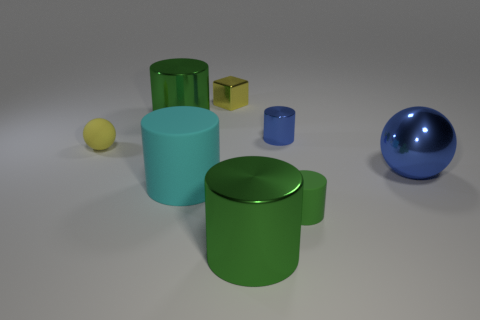There is a big cylinder left of the big matte cylinder; is it the same color as the tiny matte cylinder?
Keep it short and to the point. Yes. Is the number of small yellow shiny blocks less than the number of green cylinders?
Provide a short and direct response. Yes. There is a blue object that is the same size as the yellow block; what material is it?
Your answer should be compact. Metal. Do the tiny cube and the small matte object that is behind the small green object have the same color?
Provide a short and direct response. Yes. Is the number of cyan things to the left of the yellow ball less than the number of tiny blue matte cylinders?
Make the answer very short. No. How many metal cylinders are there?
Keep it short and to the point. 3. What shape is the large object that is behind the tiny rubber object that is on the left side of the tiny blue thing?
Your answer should be very brief. Cylinder. There is a big blue metallic object; what number of metal cylinders are behind it?
Provide a short and direct response. 2. Is the big cyan cylinder made of the same material as the big green cylinder left of the big matte cylinder?
Provide a succinct answer. No. Are there any cyan spheres that have the same size as the yellow shiny block?
Give a very brief answer. No. 